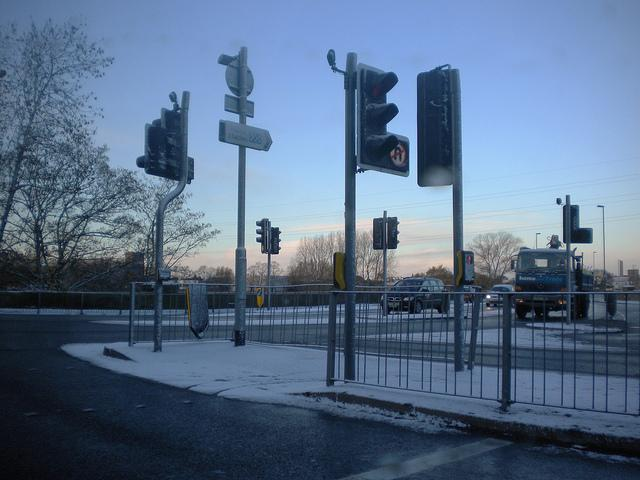What are drivers told is forbidden? u turn 